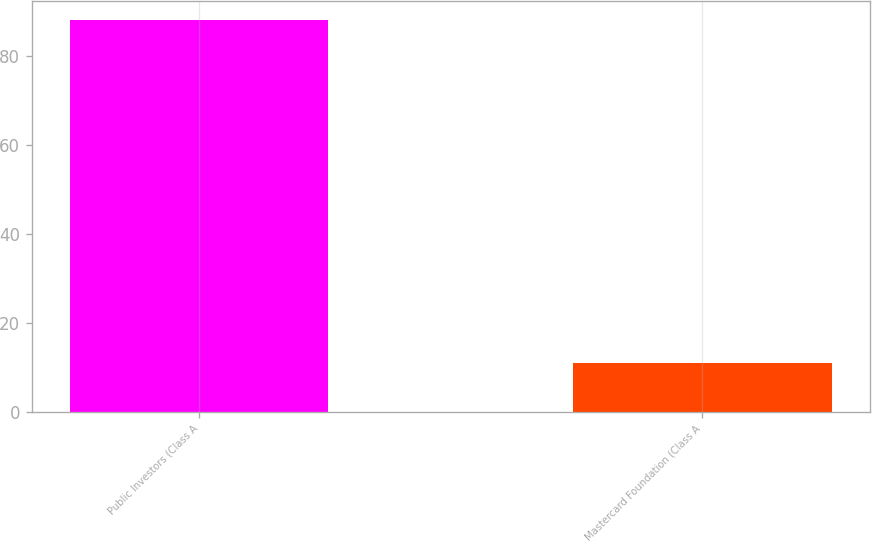<chart> <loc_0><loc_0><loc_500><loc_500><bar_chart><fcel>Public Investors (Class A<fcel>Mastercard Foundation (Class A<nl><fcel>88<fcel>10.9<nl></chart> 